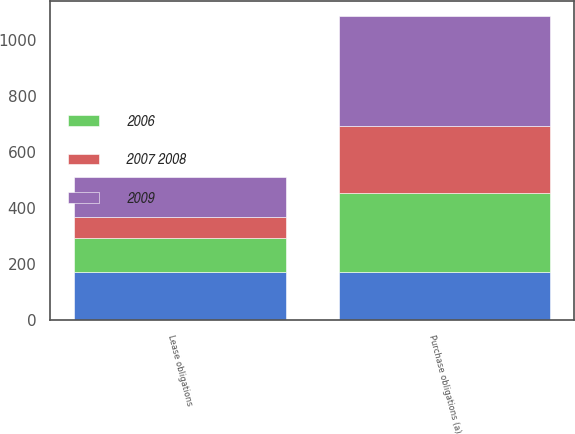Convert chart. <chart><loc_0><loc_0><loc_500><loc_500><stacked_bar_chart><ecel><fcel>Lease obligations<fcel>Purchase obligations (a)<nl><fcel>nan<fcel>172<fcel>172<nl><fcel>2009<fcel>144<fcel>393<nl><fcel>2006<fcel>119<fcel>280<nl><fcel>2007 2008<fcel>76<fcel>240<nl></chart> 